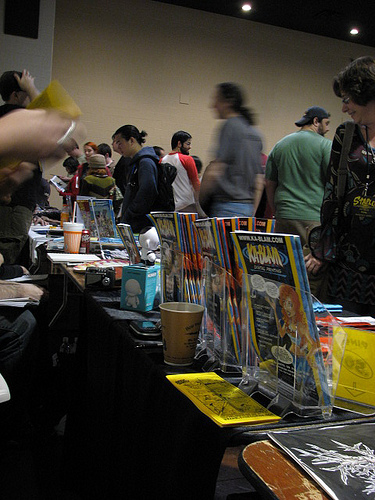<image>
Is there a cup on the table? Yes. Looking at the image, I can see the cup is positioned on top of the table, with the table providing support. 